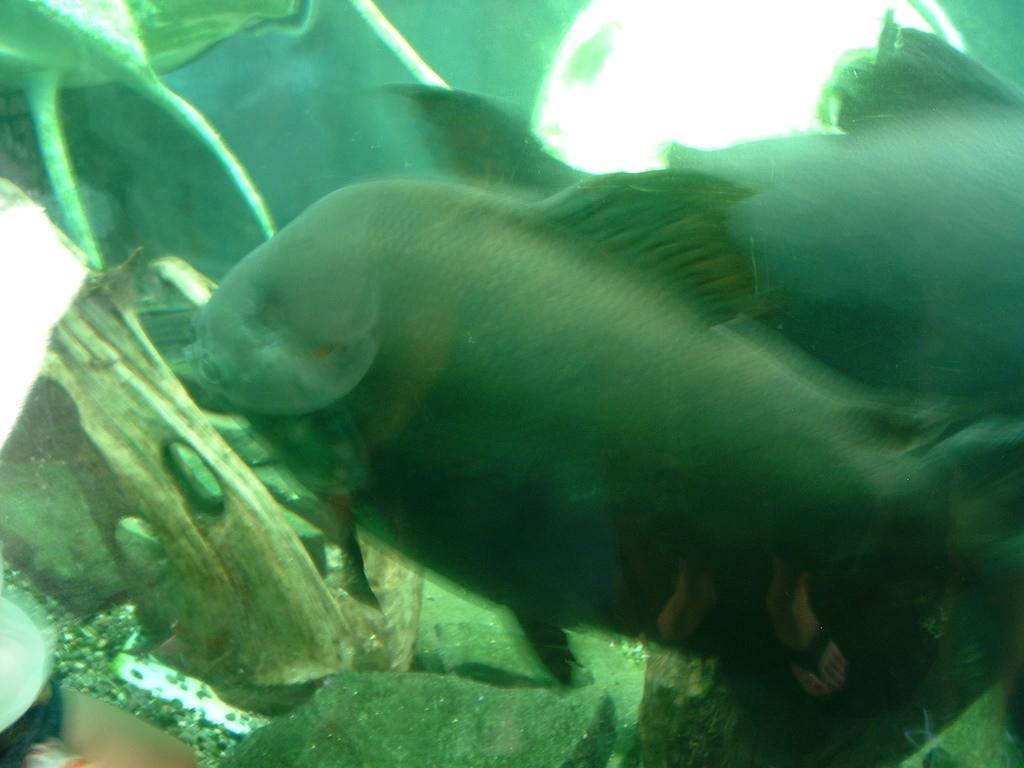Could you give a brief overview of what you see in this image? In this picture, we see the fishes. At the bottom of the picture, we see the stones. This picture might be the aquarium. In the background, it is green in color. 